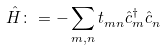Convert formula to latex. <formula><loc_0><loc_0><loc_500><loc_500>\hat { H } \colon = - \sum _ { m , n } t ^ { \ } _ { m n } \hat { c } ^ { \dag } _ { m } \hat { c } ^ { \ } _ { n }</formula> 